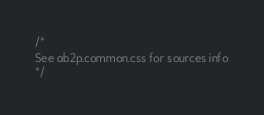Convert code to text. <code><loc_0><loc_0><loc_500><loc_500><_CSS_>/*
See ab2p.common.css for sources info
*/</code> 